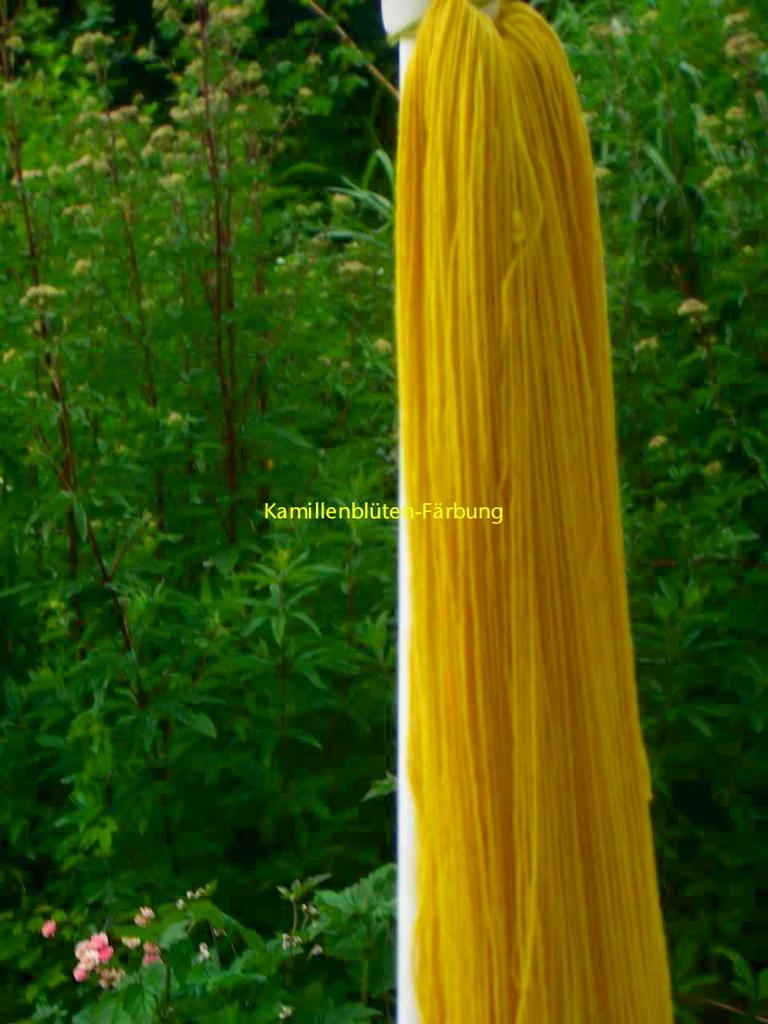What type of infrastructure is present in the image? There is fiber to the pole in the image. What other elements can be seen in the image? There are plants in the image. How much money is being exchanged between the plants in the image? There is no money exchange depicted in the image, as it features fiber infrastructure and plants. 